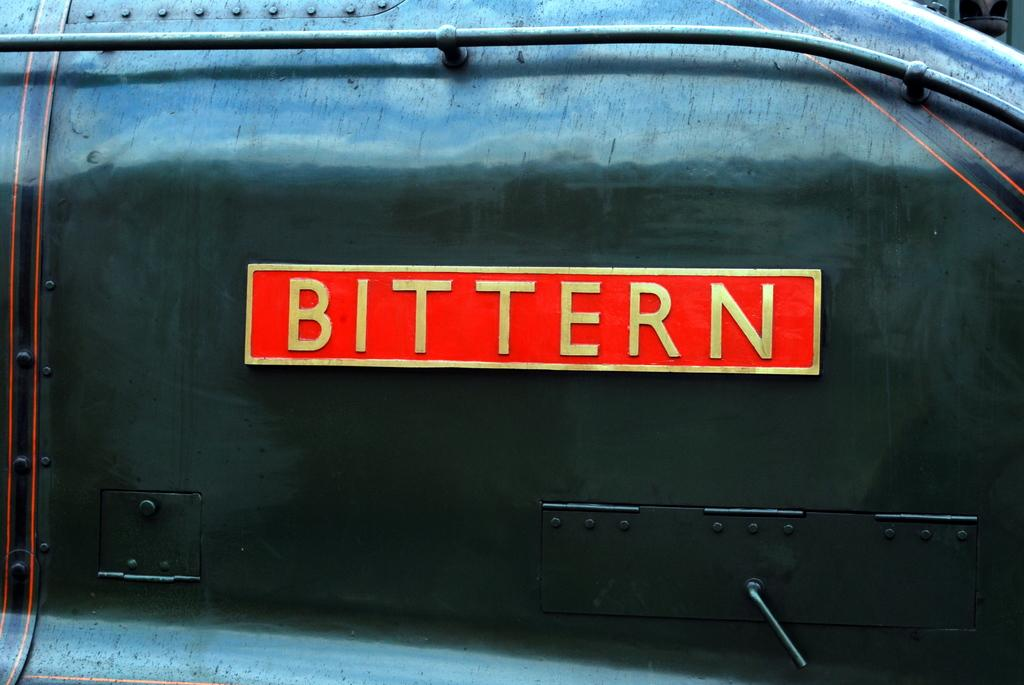<image>
Share a concise interpretation of the image provided. The back of a truck with the word Bittern on it. 